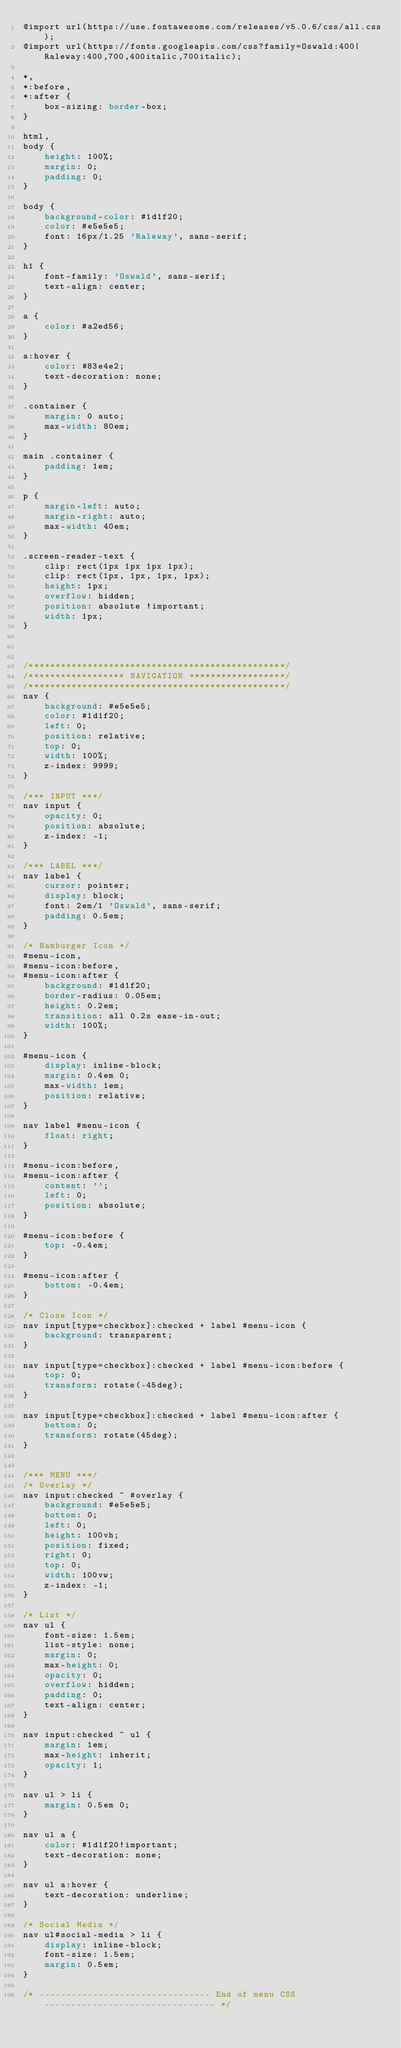Convert code to text. <code><loc_0><loc_0><loc_500><loc_500><_CSS_>@import url(https://use.fontawesome.com/releases/v5.0.6/css/all.css);
@import url(https://fonts.googleapis.com/css?family=Oswald:400|Raleway:400,700,400italic,700italic);

*,
*:before,
*:after {
    box-sizing: border-box;
}

html,
body {
    height: 100%;
    margin: 0;
    padding: 0;
}

body {
    background-color: #1d1f20;
    color: #e5e5e5;
    font: 16px/1.25 'Raleway', sans-serif;
}

h1 {
    font-family: 'Oswald', sans-serif;
    text-align: center;
}

a {
    color: #a2ed56;
}

a:hover {
    color: #83e4e2;
    text-decoration: none;
}

.container {
    margin: 0 auto;
    max-width: 80em;
}

main .container {
    padding: 1em;
}

p {
    margin-left: auto;
    margin-right: auto;
    max-width: 40em;
}

.screen-reader-text {
    clip: rect(1px 1px 1px 1px);
    clip: rect(1px, 1px, 1px, 1px);
    height: 1px;
    overflow: hidden;
    position: absolute !important;
    width: 1px;
}



/************************************************/
/****************** NAVIGATION ******************/
/************************************************/
nav {
    background: #e5e5e5;
    color: #1d1f20;
    left: 0;
    position: relative;
    top: 0;
    width: 100%;
    z-index: 9999;
}

/*** INPUT ***/
nav input {
    opacity: 0;
    position: absolute;
    z-index: -1;
}

/*** LABEL ***/
nav label {
    cursor: pointer;
    display: block;
    font: 2em/1 'Oswald', sans-serif;
    padding: 0.5em;
}

/* Hamburger Icon */
#menu-icon,
#menu-icon:before,
#menu-icon:after {
    background: #1d1f20;
    border-radius: 0.05em;
    height: 0.2em;
    transition: all 0.2s ease-in-out;
    width: 100%;
}

#menu-icon {
    display: inline-block;
    margin: 0.4em 0;
    max-width: 1em;
    position: relative;
}

nav label #menu-icon {
    float: right;
}

#menu-icon:before,
#menu-icon:after {
    content: '';
    left: 0;
    position: absolute;
}

#menu-icon:before {
    top: -0.4em;
}

#menu-icon:after {
    bottom: -0.4em;
}

/* Close Icon */
nav input[type=checkbox]:checked + label #menu-icon {
    background: transparent;
}

nav input[type=checkbox]:checked + label #menu-icon:before {
    top: 0;
    transform: rotate(-45deg);
}

nav input[type=checkbox]:checked + label #menu-icon:after {
    bottom: 0;
    transform: rotate(45deg);
}


/*** MENU ***/
/* Overlay */
nav input:checked ~ #overlay {
    background: #e5e5e5;
    bottom: 0;
    left: 0;
    height: 100vh;
    position: fixed;
    right: 0;
    top: 0;
    width: 100vw;
    z-index: -1;
}

/* List */
nav ul {
    font-size: 1.5em;
    list-style: none;
    margin: 0;
    max-height: 0;
    opacity: 0;
    overflow: hidden;
    padding: 0;
    text-align: center;
}

nav input:checked ~ ul {
    margin: 1em;
    max-height: inherit;
    opacity: 1;
}

nav ul > li {
    margin: 0.5em 0;
}

nav ul a {
    color: #1d1f20!important;
    text-decoration: none;
}

nav ul a:hover {
    text-decoration: underline;
}

/* Social Media */
nav ul#social-media > li {
    display: inline-block;
    font-size: 1.5em;
    margin: 0.5em;
}

/* -------------------------------- End of menu CSS -------------------------------- */</code> 